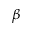Convert formula to latex. <formula><loc_0><loc_0><loc_500><loc_500>\beta</formula> 